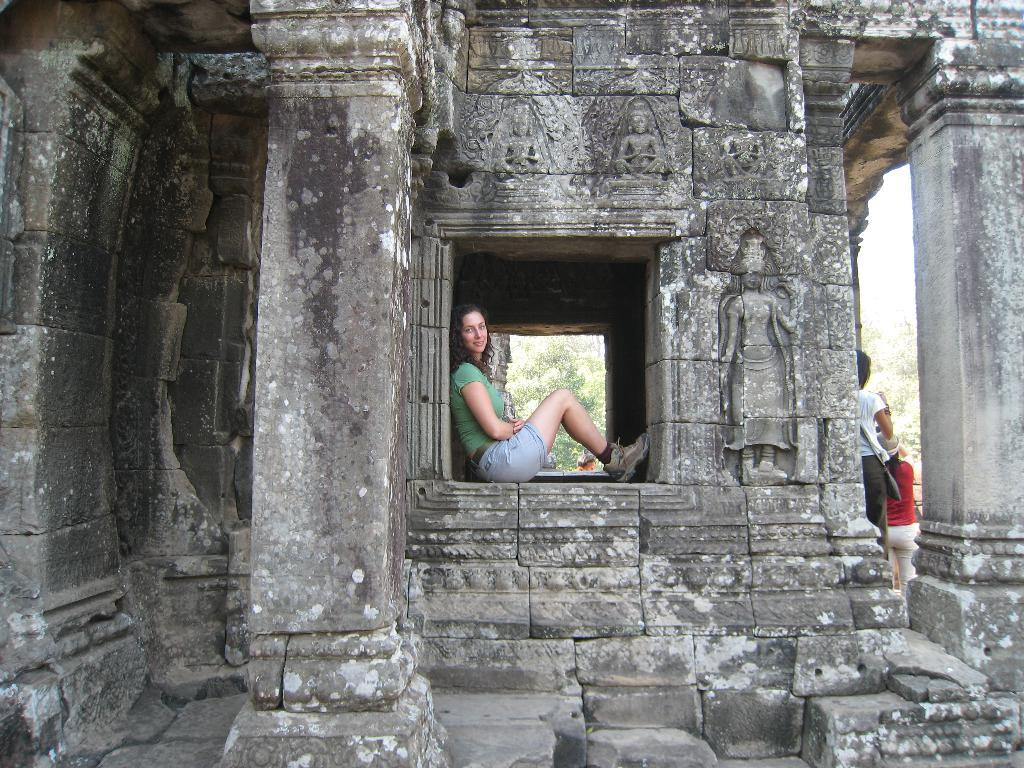How many people are present in the image? There are two people in the image. What type of natural elements can be seen in the image? There are trees in the image. What type of artistic objects are present in the image? There are sculptures in the image. What type of verse can be seen written on the spot in the image? There is no verse or spot present in the image; it features two people, trees, and sculptures. 